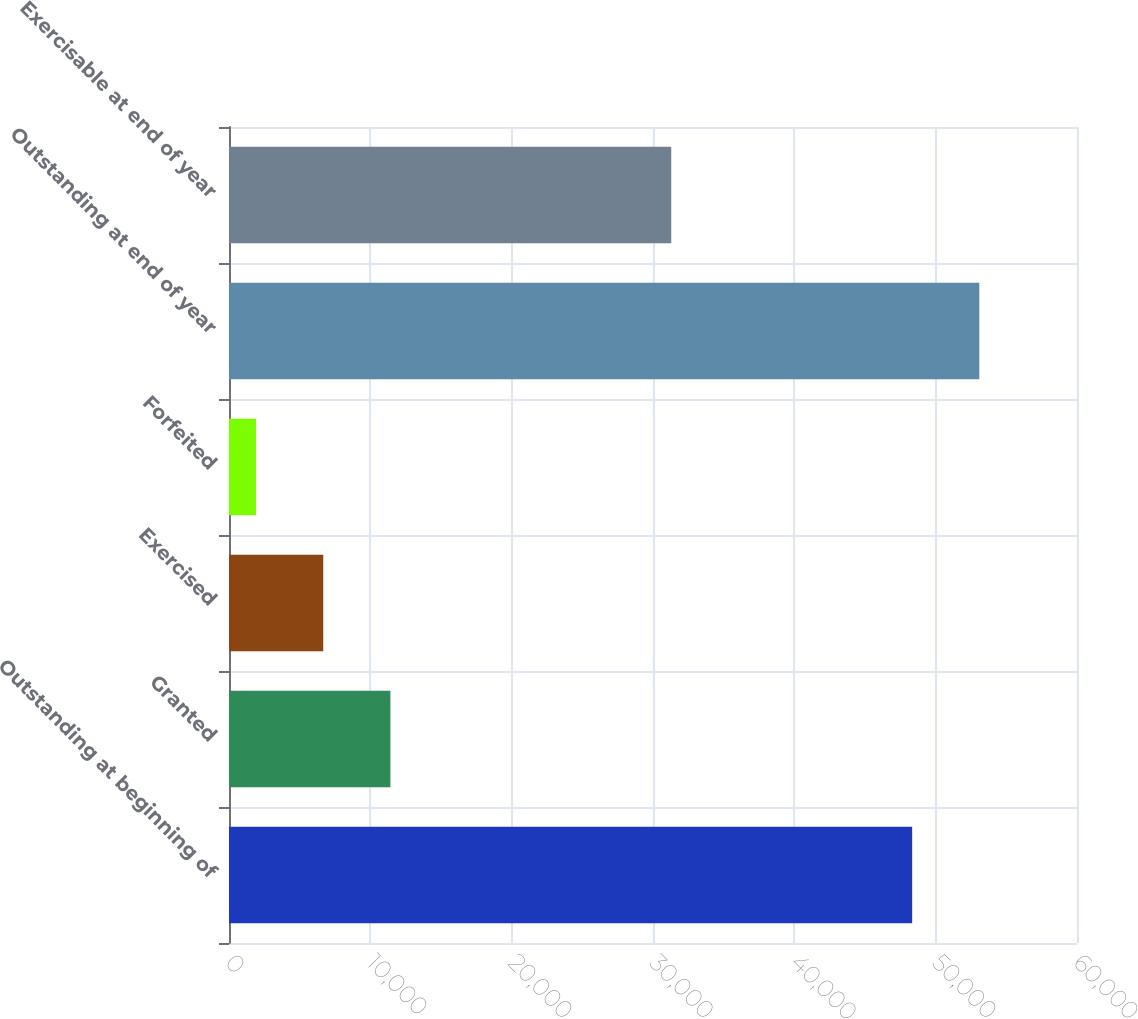Convert chart. <chart><loc_0><loc_0><loc_500><loc_500><bar_chart><fcel>Outstanding at beginning of<fcel>Granted<fcel>Exercised<fcel>Forfeited<fcel>Outstanding at end of year<fcel>Exercisable at end of year<nl><fcel>48337<fcel>11419.4<fcel>6668.2<fcel>1917<fcel>53088.2<fcel>31291<nl></chart> 